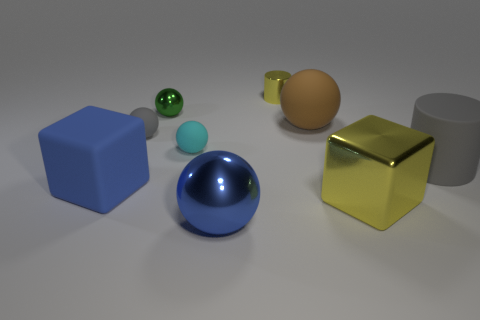There is a shiny thing that is the same color as the rubber cube; what shape is it?
Offer a very short reply. Sphere. What number of things are either small matte objects left of the cyan rubber ball or yellow cylinders?
Give a very brief answer. 2. What number of matte objects are to the right of the tiny ball behind the tiny gray object?
Make the answer very short. 3. Is the number of blue matte things in front of the blue rubber block less than the number of small yellow metallic cylinders right of the large blue sphere?
Your answer should be very brief. Yes. There is a yellow metal thing that is in front of the gray thing right of the brown thing; what is its shape?
Provide a short and direct response. Cube. How many other things are the same material as the tiny gray thing?
Provide a short and direct response. 4. Is the number of cyan objects greater than the number of small brown metal spheres?
Offer a very short reply. Yes. There is a metal ball behind the blue thing that is behind the blue thing right of the tiny cyan matte sphere; what is its size?
Offer a terse response. Small. There is a matte block; is its size the same as the yellow object in front of the large brown ball?
Provide a succinct answer. Yes. Are there fewer rubber things that are in front of the big gray cylinder than objects?
Make the answer very short. Yes. 